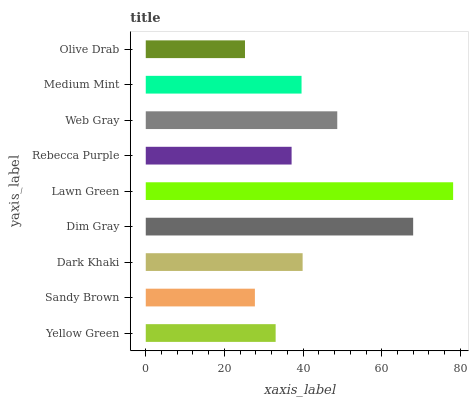Is Olive Drab the minimum?
Answer yes or no. Yes. Is Lawn Green the maximum?
Answer yes or no. Yes. Is Sandy Brown the minimum?
Answer yes or no. No. Is Sandy Brown the maximum?
Answer yes or no. No. Is Yellow Green greater than Sandy Brown?
Answer yes or no. Yes. Is Sandy Brown less than Yellow Green?
Answer yes or no. Yes. Is Sandy Brown greater than Yellow Green?
Answer yes or no. No. Is Yellow Green less than Sandy Brown?
Answer yes or no. No. Is Medium Mint the high median?
Answer yes or no. Yes. Is Medium Mint the low median?
Answer yes or no. Yes. Is Olive Drab the high median?
Answer yes or no. No. Is Sandy Brown the low median?
Answer yes or no. No. 